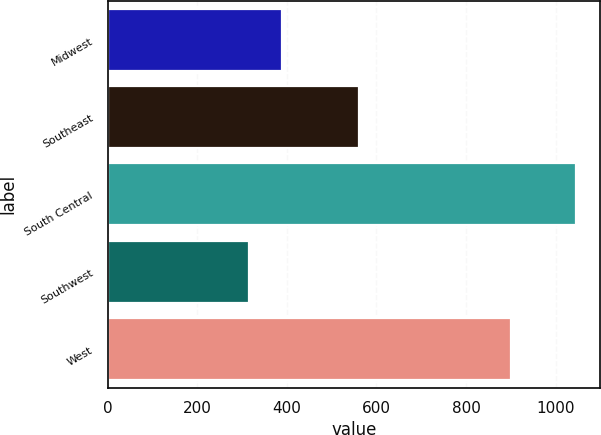<chart> <loc_0><loc_0><loc_500><loc_500><bar_chart><fcel>Midwest<fcel>Southeast<fcel>South Central<fcel>Southwest<fcel>West<nl><fcel>388<fcel>560.8<fcel>1045.9<fcel>314.9<fcel>899.6<nl></chart> 